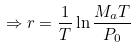Convert formula to latex. <formula><loc_0><loc_0><loc_500><loc_500>\Rightarrow r = \frac { 1 } { T } \ln \frac { M _ { a } T } { P _ { 0 } }</formula> 